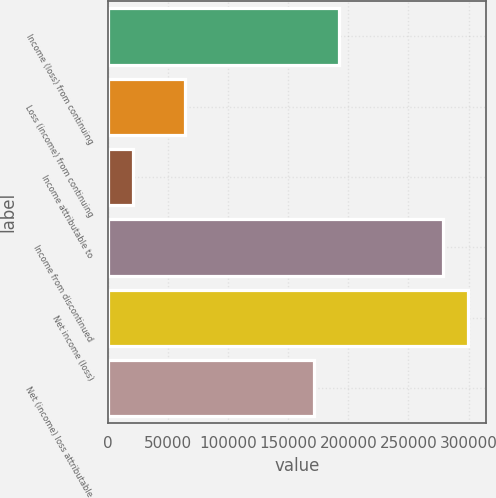<chart> <loc_0><loc_0><loc_500><loc_500><bar_chart><fcel>Income (loss) from continuing<fcel>Loss (income) from continuing<fcel>Income attributable to<fcel>Income from discontinued<fcel>Net income (loss)<fcel>Net (income) loss attributable<nl><fcel>192705<fcel>64235.6<fcel>21412.4<fcel>278352<fcel>299763<fcel>171294<nl></chart> 